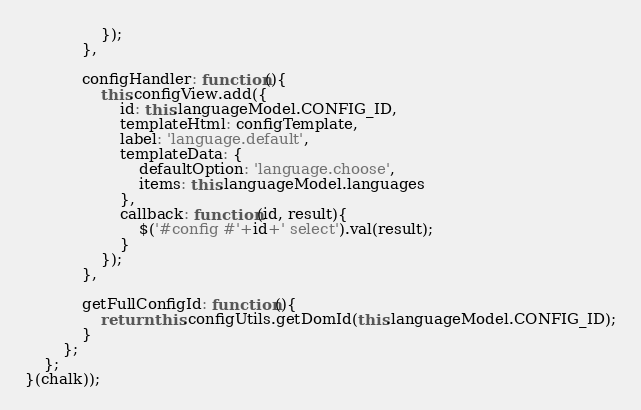<code> <loc_0><loc_0><loc_500><loc_500><_JavaScript_>                });
            },

            configHandler: function(){
                this.configView.add({
                    id: this.languageModel.CONFIG_ID,
                    templateHtml: configTemplate,
                    label: 'language.default',
                    templateData: {
                        defaultOption: 'language.choose',
                        items: this.languageModel.languages
                    },
                    callback: function(id, result){
                        $('#config #'+id+' select').val(result);
                    }
                });
            },

            getFullConfigId: function(){
                return this.configUtils.getDomId(this.languageModel.CONFIG_ID);
            }
        };
    };
}(chalk));</code> 